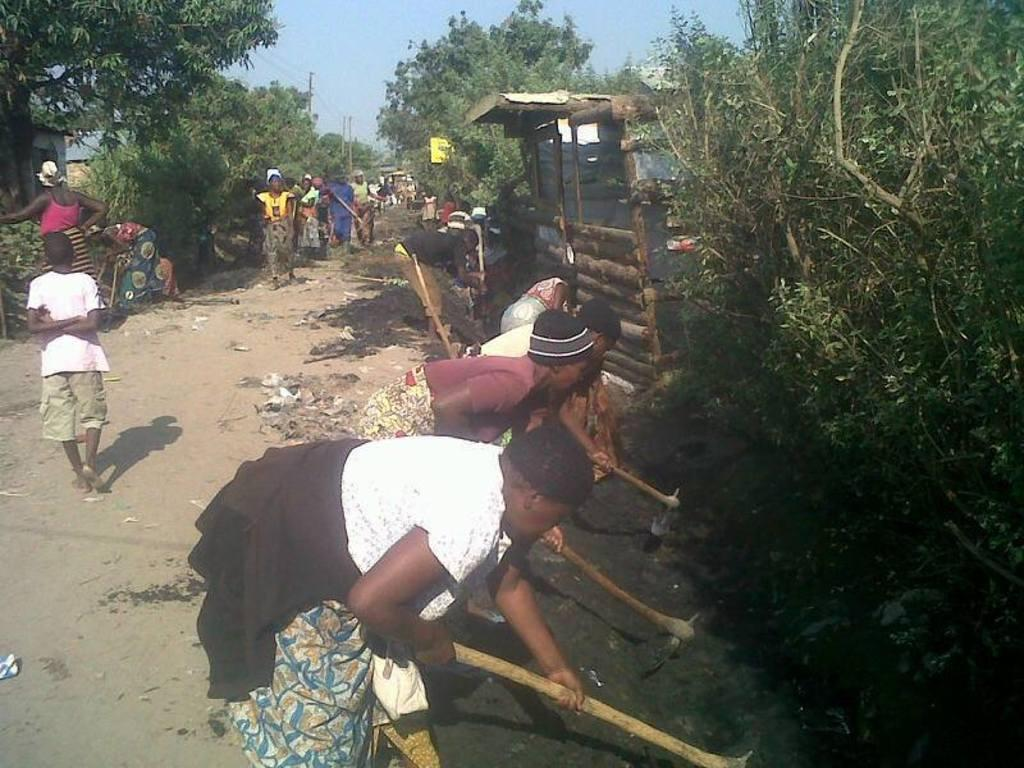How many people are in the image? There is a group of people in the image. What are some of the people doing in the image? Some people are walking, and some people are using digging tools. What type of vegetation can be seen in the image? There are trees visible in the image. What structures can be seen in the image? There are poles in the image. What type of lawyer is present in the image? There is no lawyer present in the image. Can you tell me how many train tracks are visible in the image? A: There are no train tracks visible in the image. 